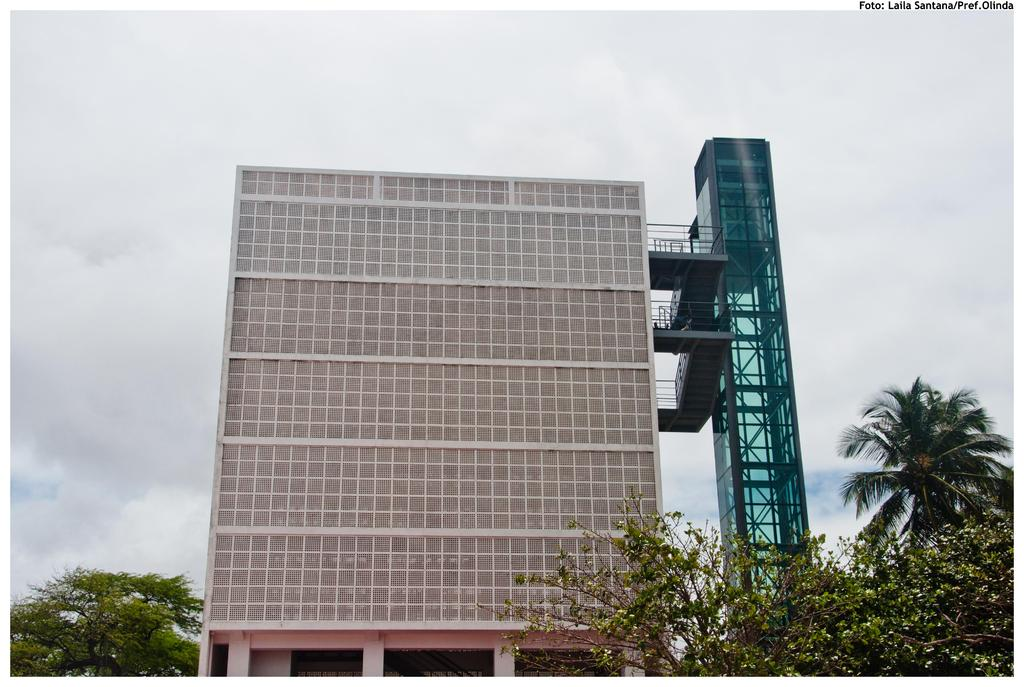What is located in the foreground of the image? There are trees and a building in the foreground of the image. What can be seen in the background of the image? The sky and clouds are visible in the background of the image. What type of fruit is hanging from the trees in the image? There is no fruit visible on the trees in the image. Can you tell me where the secretary is located in the image? There is no secretary present in the image. 